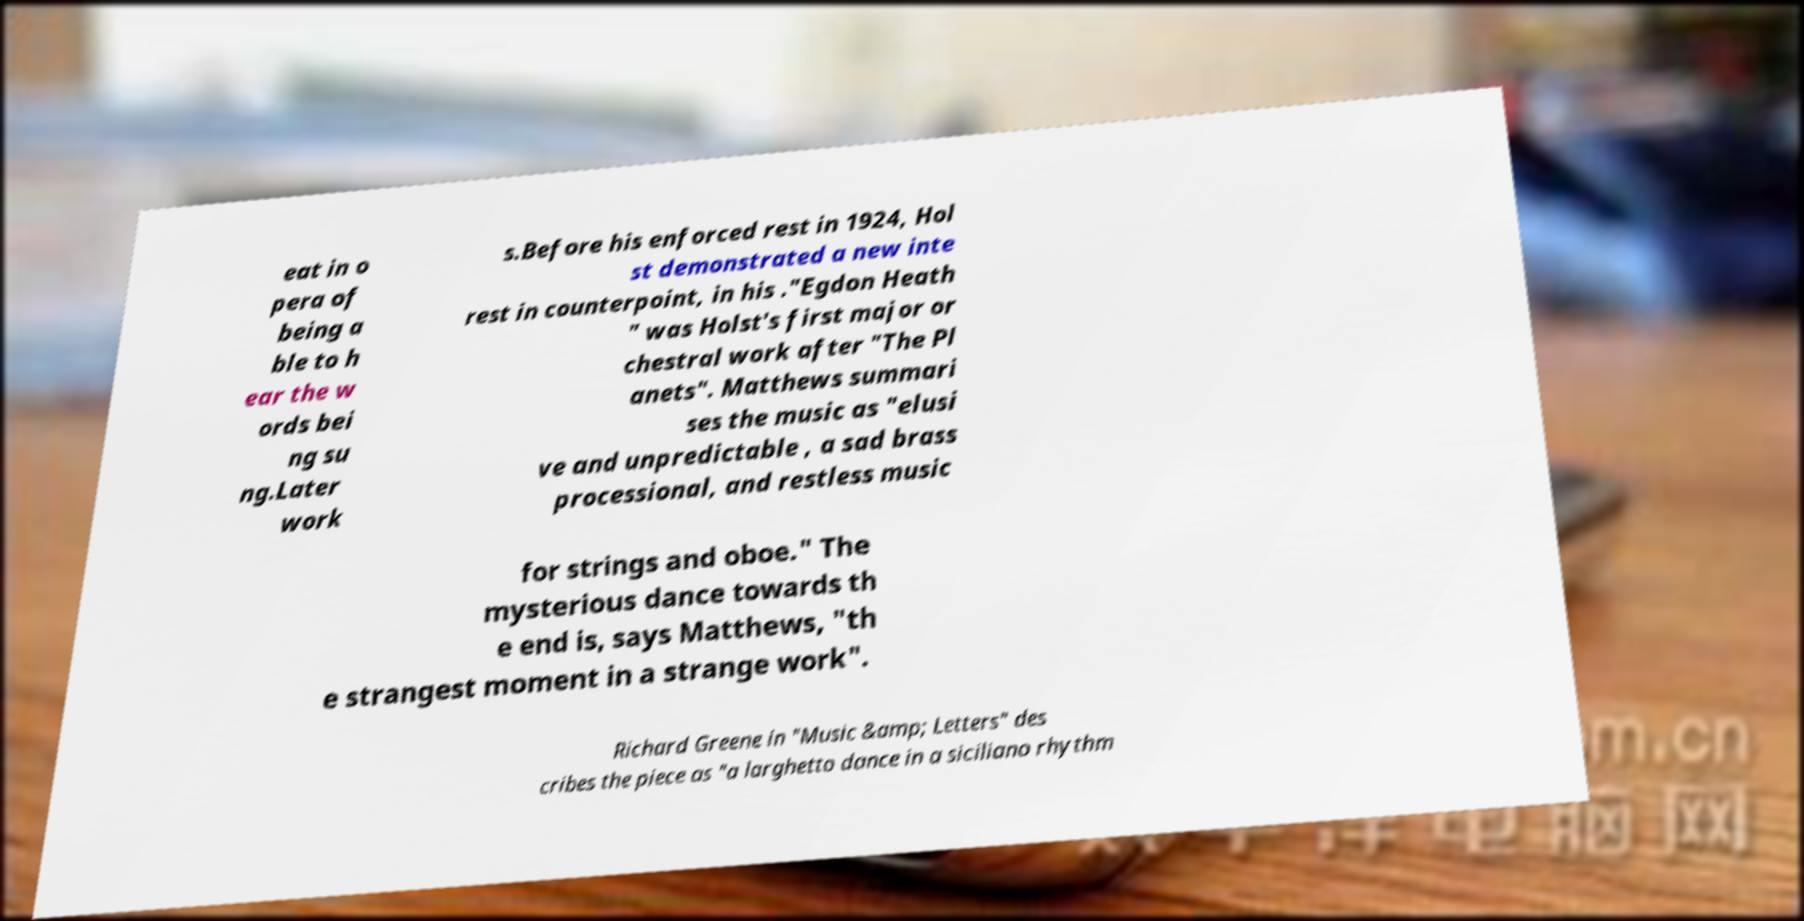Could you extract and type out the text from this image? eat in o pera of being a ble to h ear the w ords bei ng su ng.Later work s.Before his enforced rest in 1924, Hol st demonstrated a new inte rest in counterpoint, in his ."Egdon Heath " was Holst's first major or chestral work after "The Pl anets". Matthews summari ses the music as "elusi ve and unpredictable , a sad brass processional, and restless music for strings and oboe." The mysterious dance towards th e end is, says Matthews, "th e strangest moment in a strange work". Richard Greene in "Music &amp; Letters" des cribes the piece as "a larghetto dance in a siciliano rhythm 